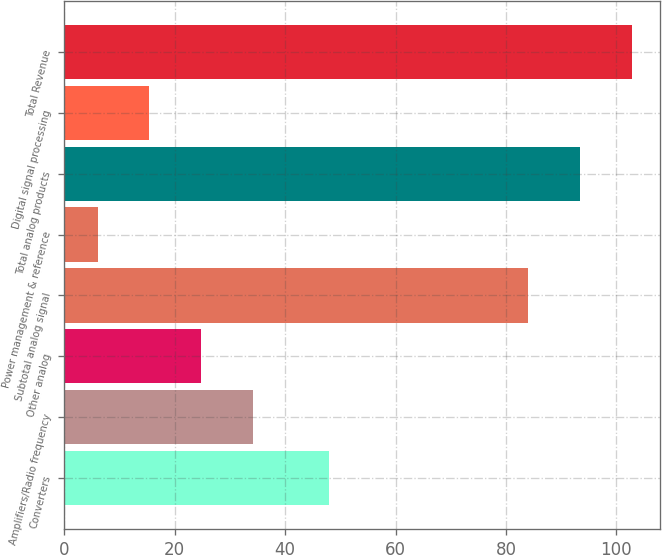<chart> <loc_0><loc_0><loc_500><loc_500><bar_chart><fcel>Converters<fcel>Amplifiers/Radio frequency<fcel>Other analog<fcel>Subtotal analog signal<fcel>Power management & reference<fcel>Total analog products<fcel>Digital signal processing<fcel>Total Revenue<nl><fcel>48<fcel>34.2<fcel>24.8<fcel>84<fcel>6<fcel>93.4<fcel>15.4<fcel>102.8<nl></chart> 